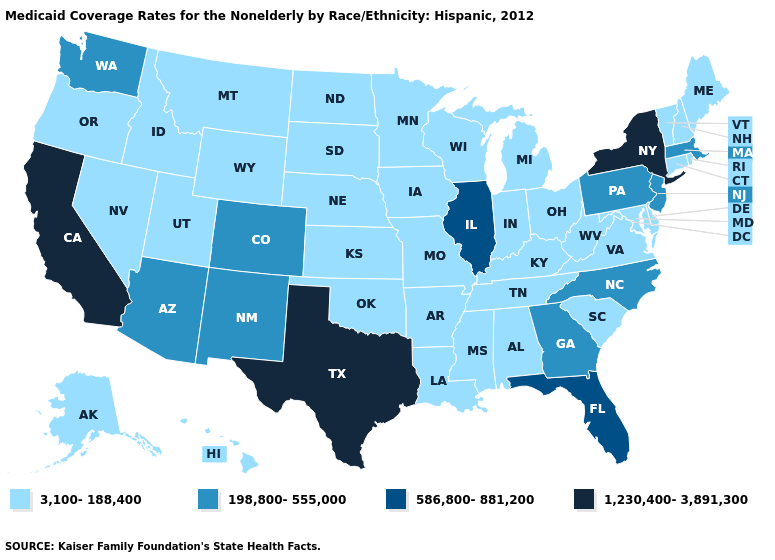Does Florida have a higher value than Illinois?
Keep it brief. No. Does the first symbol in the legend represent the smallest category?
Concise answer only. Yes. Which states have the lowest value in the USA?
Answer briefly. Alabama, Alaska, Arkansas, Connecticut, Delaware, Hawaii, Idaho, Indiana, Iowa, Kansas, Kentucky, Louisiana, Maine, Maryland, Michigan, Minnesota, Mississippi, Missouri, Montana, Nebraska, Nevada, New Hampshire, North Dakota, Ohio, Oklahoma, Oregon, Rhode Island, South Carolina, South Dakota, Tennessee, Utah, Vermont, Virginia, West Virginia, Wisconsin, Wyoming. Is the legend a continuous bar?
Keep it brief. No. Which states hav the highest value in the West?
Answer briefly. California. Which states hav the highest value in the Northeast?
Be succinct. New York. Does New Mexico have a higher value than Georgia?
Give a very brief answer. No. Does New Jersey have the lowest value in the USA?
Write a very short answer. No. Which states have the highest value in the USA?
Concise answer only. California, New York, Texas. Does Montana have the same value as Indiana?
Short answer required. Yes. Name the states that have a value in the range 198,800-555,000?
Keep it brief. Arizona, Colorado, Georgia, Massachusetts, New Jersey, New Mexico, North Carolina, Pennsylvania, Washington. What is the value of Oklahoma?
Keep it brief. 3,100-188,400. What is the value of North Dakota?
Concise answer only. 3,100-188,400. Name the states that have a value in the range 586,800-881,200?
Short answer required. Florida, Illinois. What is the value of Indiana?
Keep it brief. 3,100-188,400. 